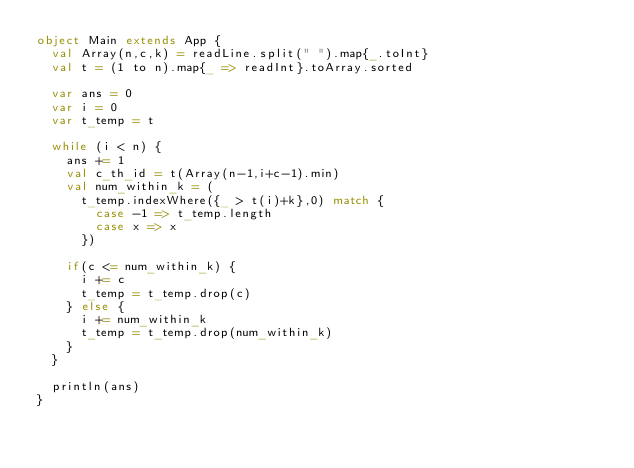<code> <loc_0><loc_0><loc_500><loc_500><_Scala_>object Main extends App {
  val Array(n,c,k) = readLine.split(" ").map{_.toInt}
  val t = (1 to n).map{_ => readInt}.toArray.sorted
  
  var ans = 0
  var i = 0
  var t_temp = t
  
  while (i < n) {
    ans += 1
    val c_th_id = t(Array(n-1,i+c-1).min)
    val num_within_k = (
      t_temp.indexWhere({_ > t(i)+k},0) match {
        case -1 => t_temp.length
        case x => x
      })
    
    if(c <= num_within_k) {
      i += c
      t_temp = t_temp.drop(c)
    } else {
      i += num_within_k
      t_temp = t_temp.drop(num_within_k)
    }
  }
  
  println(ans)
}</code> 